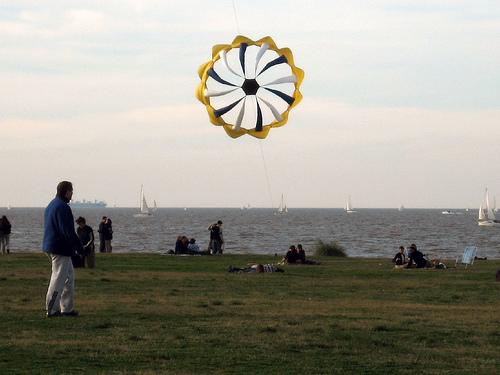Where is the boy looking?
Quick response, please. Up. What color is the man's outfit?
Answer briefly. Blue. What kind of boats are in the distance?
Be succinct. Sailboats. Are two people kissing in this picture?
Answer briefly. Yes. What  is under the boat?
Write a very short answer. Water. What is in the sky?
Be succinct. Kite. 